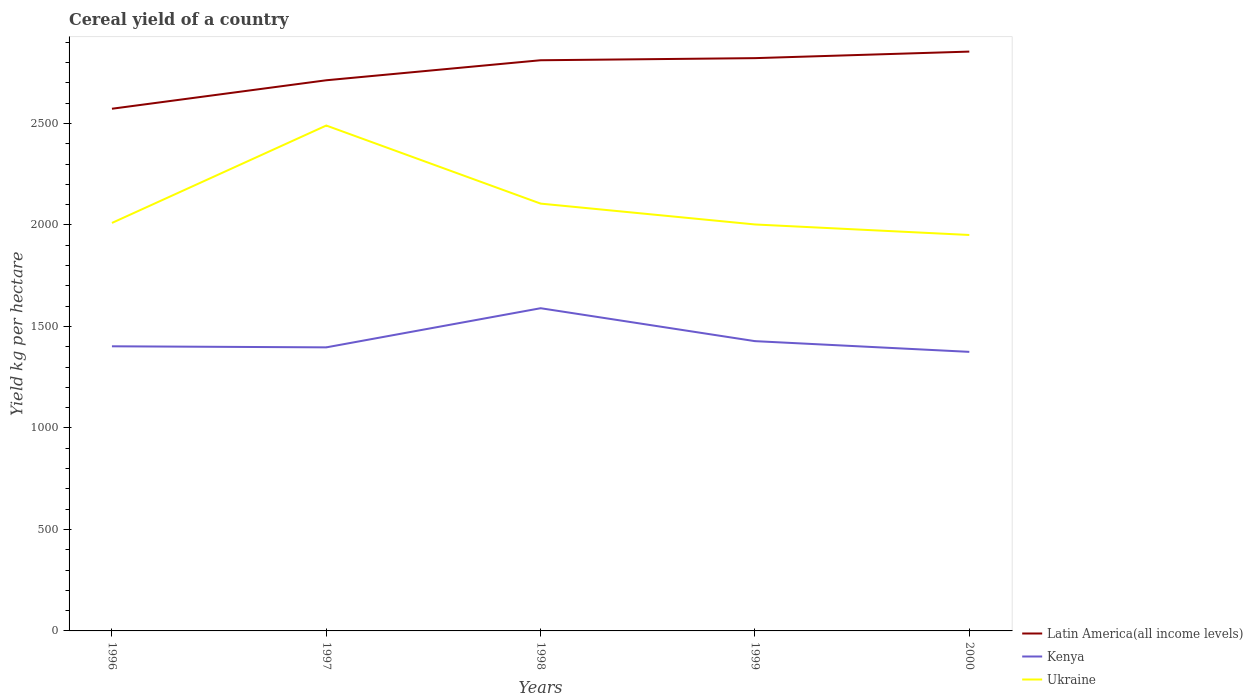How many different coloured lines are there?
Provide a short and direct response. 3. Does the line corresponding to Ukraine intersect with the line corresponding to Kenya?
Keep it short and to the point. No. Across all years, what is the maximum total cereal yield in Latin America(all income levels)?
Give a very brief answer. 2572.81. What is the total total cereal yield in Kenya in the graph?
Keep it short and to the point. 162.23. What is the difference between the highest and the second highest total cereal yield in Ukraine?
Ensure brevity in your answer.  539.33. How many lines are there?
Offer a very short reply. 3. How many years are there in the graph?
Give a very brief answer. 5. What is the difference between two consecutive major ticks on the Y-axis?
Offer a terse response. 500. Does the graph contain any zero values?
Your response must be concise. No. Where does the legend appear in the graph?
Offer a very short reply. Bottom right. What is the title of the graph?
Give a very brief answer. Cereal yield of a country. What is the label or title of the Y-axis?
Your answer should be very brief. Yield kg per hectare. What is the Yield kg per hectare in Latin America(all income levels) in 1996?
Offer a very short reply. 2572.81. What is the Yield kg per hectare in Kenya in 1996?
Keep it short and to the point. 1402.37. What is the Yield kg per hectare of Ukraine in 1996?
Provide a short and direct response. 2010.14. What is the Yield kg per hectare of Latin America(all income levels) in 1997?
Your answer should be compact. 2713.1. What is the Yield kg per hectare of Kenya in 1997?
Your answer should be compact. 1397.1. What is the Yield kg per hectare of Ukraine in 1997?
Offer a very short reply. 2490.11. What is the Yield kg per hectare of Latin America(all income levels) in 1998?
Offer a very short reply. 2811.75. What is the Yield kg per hectare in Kenya in 1998?
Provide a succinct answer. 1589.97. What is the Yield kg per hectare in Ukraine in 1998?
Offer a very short reply. 2105.38. What is the Yield kg per hectare of Latin America(all income levels) in 1999?
Ensure brevity in your answer.  2822.08. What is the Yield kg per hectare of Kenya in 1999?
Make the answer very short. 1427.74. What is the Yield kg per hectare of Ukraine in 1999?
Provide a succinct answer. 2002.63. What is the Yield kg per hectare of Latin America(all income levels) in 2000?
Ensure brevity in your answer.  2854.4. What is the Yield kg per hectare of Kenya in 2000?
Your answer should be very brief. 1374.96. What is the Yield kg per hectare of Ukraine in 2000?
Offer a very short reply. 1950.78. Across all years, what is the maximum Yield kg per hectare of Latin America(all income levels)?
Offer a very short reply. 2854.4. Across all years, what is the maximum Yield kg per hectare in Kenya?
Ensure brevity in your answer.  1589.97. Across all years, what is the maximum Yield kg per hectare of Ukraine?
Provide a succinct answer. 2490.11. Across all years, what is the minimum Yield kg per hectare of Latin America(all income levels)?
Keep it short and to the point. 2572.81. Across all years, what is the minimum Yield kg per hectare of Kenya?
Give a very brief answer. 1374.96. Across all years, what is the minimum Yield kg per hectare of Ukraine?
Provide a short and direct response. 1950.78. What is the total Yield kg per hectare of Latin America(all income levels) in the graph?
Your answer should be compact. 1.38e+04. What is the total Yield kg per hectare of Kenya in the graph?
Make the answer very short. 7192.14. What is the total Yield kg per hectare of Ukraine in the graph?
Offer a terse response. 1.06e+04. What is the difference between the Yield kg per hectare in Latin America(all income levels) in 1996 and that in 1997?
Provide a short and direct response. -140.3. What is the difference between the Yield kg per hectare in Kenya in 1996 and that in 1997?
Provide a short and direct response. 5.27. What is the difference between the Yield kg per hectare in Ukraine in 1996 and that in 1997?
Keep it short and to the point. -479.97. What is the difference between the Yield kg per hectare of Latin America(all income levels) in 1996 and that in 1998?
Your response must be concise. -238.94. What is the difference between the Yield kg per hectare of Kenya in 1996 and that in 1998?
Make the answer very short. -187.6. What is the difference between the Yield kg per hectare of Ukraine in 1996 and that in 1998?
Keep it short and to the point. -95.25. What is the difference between the Yield kg per hectare of Latin America(all income levels) in 1996 and that in 1999?
Make the answer very short. -249.27. What is the difference between the Yield kg per hectare in Kenya in 1996 and that in 1999?
Provide a succinct answer. -25.37. What is the difference between the Yield kg per hectare in Ukraine in 1996 and that in 1999?
Offer a very short reply. 7.5. What is the difference between the Yield kg per hectare of Latin America(all income levels) in 1996 and that in 2000?
Make the answer very short. -281.59. What is the difference between the Yield kg per hectare in Kenya in 1996 and that in 2000?
Provide a succinct answer. 27.41. What is the difference between the Yield kg per hectare of Ukraine in 1996 and that in 2000?
Keep it short and to the point. 59.36. What is the difference between the Yield kg per hectare in Latin America(all income levels) in 1997 and that in 1998?
Your response must be concise. -98.64. What is the difference between the Yield kg per hectare in Kenya in 1997 and that in 1998?
Your response must be concise. -192.87. What is the difference between the Yield kg per hectare in Ukraine in 1997 and that in 1998?
Give a very brief answer. 384.72. What is the difference between the Yield kg per hectare of Latin America(all income levels) in 1997 and that in 1999?
Offer a terse response. -108.97. What is the difference between the Yield kg per hectare of Kenya in 1997 and that in 1999?
Ensure brevity in your answer.  -30.64. What is the difference between the Yield kg per hectare in Ukraine in 1997 and that in 1999?
Ensure brevity in your answer.  487.47. What is the difference between the Yield kg per hectare in Latin America(all income levels) in 1997 and that in 2000?
Offer a terse response. -141.29. What is the difference between the Yield kg per hectare of Kenya in 1997 and that in 2000?
Ensure brevity in your answer.  22.14. What is the difference between the Yield kg per hectare of Ukraine in 1997 and that in 2000?
Your answer should be compact. 539.33. What is the difference between the Yield kg per hectare of Latin America(all income levels) in 1998 and that in 1999?
Ensure brevity in your answer.  -10.33. What is the difference between the Yield kg per hectare in Kenya in 1998 and that in 1999?
Keep it short and to the point. 162.23. What is the difference between the Yield kg per hectare in Ukraine in 1998 and that in 1999?
Your answer should be compact. 102.75. What is the difference between the Yield kg per hectare of Latin America(all income levels) in 1998 and that in 2000?
Offer a terse response. -42.65. What is the difference between the Yield kg per hectare in Kenya in 1998 and that in 2000?
Offer a terse response. 215. What is the difference between the Yield kg per hectare of Ukraine in 1998 and that in 2000?
Provide a succinct answer. 154.61. What is the difference between the Yield kg per hectare in Latin America(all income levels) in 1999 and that in 2000?
Your response must be concise. -32.32. What is the difference between the Yield kg per hectare in Kenya in 1999 and that in 2000?
Give a very brief answer. 52.78. What is the difference between the Yield kg per hectare in Ukraine in 1999 and that in 2000?
Offer a terse response. 51.86. What is the difference between the Yield kg per hectare in Latin America(all income levels) in 1996 and the Yield kg per hectare in Kenya in 1997?
Your response must be concise. 1175.71. What is the difference between the Yield kg per hectare of Latin America(all income levels) in 1996 and the Yield kg per hectare of Ukraine in 1997?
Your answer should be very brief. 82.7. What is the difference between the Yield kg per hectare in Kenya in 1996 and the Yield kg per hectare in Ukraine in 1997?
Give a very brief answer. -1087.73. What is the difference between the Yield kg per hectare in Latin America(all income levels) in 1996 and the Yield kg per hectare in Kenya in 1998?
Your answer should be very brief. 982.84. What is the difference between the Yield kg per hectare in Latin America(all income levels) in 1996 and the Yield kg per hectare in Ukraine in 1998?
Give a very brief answer. 467.42. What is the difference between the Yield kg per hectare in Kenya in 1996 and the Yield kg per hectare in Ukraine in 1998?
Make the answer very short. -703.01. What is the difference between the Yield kg per hectare in Latin America(all income levels) in 1996 and the Yield kg per hectare in Kenya in 1999?
Offer a very short reply. 1145.06. What is the difference between the Yield kg per hectare in Latin America(all income levels) in 1996 and the Yield kg per hectare in Ukraine in 1999?
Keep it short and to the point. 570.17. What is the difference between the Yield kg per hectare in Kenya in 1996 and the Yield kg per hectare in Ukraine in 1999?
Offer a terse response. -600.26. What is the difference between the Yield kg per hectare of Latin America(all income levels) in 1996 and the Yield kg per hectare of Kenya in 2000?
Provide a short and direct response. 1197.84. What is the difference between the Yield kg per hectare of Latin America(all income levels) in 1996 and the Yield kg per hectare of Ukraine in 2000?
Provide a short and direct response. 622.03. What is the difference between the Yield kg per hectare in Kenya in 1996 and the Yield kg per hectare in Ukraine in 2000?
Offer a very short reply. -548.41. What is the difference between the Yield kg per hectare in Latin America(all income levels) in 1997 and the Yield kg per hectare in Kenya in 1998?
Make the answer very short. 1123.14. What is the difference between the Yield kg per hectare of Latin America(all income levels) in 1997 and the Yield kg per hectare of Ukraine in 1998?
Provide a short and direct response. 607.72. What is the difference between the Yield kg per hectare in Kenya in 1997 and the Yield kg per hectare in Ukraine in 1998?
Your response must be concise. -708.28. What is the difference between the Yield kg per hectare of Latin America(all income levels) in 1997 and the Yield kg per hectare of Kenya in 1999?
Your answer should be very brief. 1285.36. What is the difference between the Yield kg per hectare of Latin America(all income levels) in 1997 and the Yield kg per hectare of Ukraine in 1999?
Give a very brief answer. 710.47. What is the difference between the Yield kg per hectare of Kenya in 1997 and the Yield kg per hectare of Ukraine in 1999?
Make the answer very short. -605.53. What is the difference between the Yield kg per hectare of Latin America(all income levels) in 1997 and the Yield kg per hectare of Kenya in 2000?
Make the answer very short. 1338.14. What is the difference between the Yield kg per hectare of Latin America(all income levels) in 1997 and the Yield kg per hectare of Ukraine in 2000?
Provide a short and direct response. 762.33. What is the difference between the Yield kg per hectare in Kenya in 1997 and the Yield kg per hectare in Ukraine in 2000?
Offer a very short reply. -553.68. What is the difference between the Yield kg per hectare in Latin America(all income levels) in 1998 and the Yield kg per hectare in Kenya in 1999?
Make the answer very short. 1384.01. What is the difference between the Yield kg per hectare of Latin America(all income levels) in 1998 and the Yield kg per hectare of Ukraine in 1999?
Provide a succinct answer. 809.12. What is the difference between the Yield kg per hectare in Kenya in 1998 and the Yield kg per hectare in Ukraine in 1999?
Your answer should be very brief. -412.67. What is the difference between the Yield kg per hectare in Latin America(all income levels) in 1998 and the Yield kg per hectare in Kenya in 2000?
Provide a succinct answer. 1436.79. What is the difference between the Yield kg per hectare of Latin America(all income levels) in 1998 and the Yield kg per hectare of Ukraine in 2000?
Ensure brevity in your answer.  860.97. What is the difference between the Yield kg per hectare in Kenya in 1998 and the Yield kg per hectare in Ukraine in 2000?
Offer a terse response. -360.81. What is the difference between the Yield kg per hectare in Latin America(all income levels) in 1999 and the Yield kg per hectare in Kenya in 2000?
Your response must be concise. 1447.12. What is the difference between the Yield kg per hectare in Latin America(all income levels) in 1999 and the Yield kg per hectare in Ukraine in 2000?
Offer a very short reply. 871.3. What is the difference between the Yield kg per hectare of Kenya in 1999 and the Yield kg per hectare of Ukraine in 2000?
Provide a succinct answer. -523.03. What is the average Yield kg per hectare of Latin America(all income levels) per year?
Make the answer very short. 2754.83. What is the average Yield kg per hectare in Kenya per year?
Provide a succinct answer. 1438.43. What is the average Yield kg per hectare of Ukraine per year?
Give a very brief answer. 2111.81. In the year 1996, what is the difference between the Yield kg per hectare in Latin America(all income levels) and Yield kg per hectare in Kenya?
Offer a very short reply. 1170.43. In the year 1996, what is the difference between the Yield kg per hectare of Latin America(all income levels) and Yield kg per hectare of Ukraine?
Your response must be concise. 562.67. In the year 1996, what is the difference between the Yield kg per hectare of Kenya and Yield kg per hectare of Ukraine?
Provide a succinct answer. -607.77. In the year 1997, what is the difference between the Yield kg per hectare in Latin America(all income levels) and Yield kg per hectare in Kenya?
Offer a terse response. 1316.01. In the year 1997, what is the difference between the Yield kg per hectare of Latin America(all income levels) and Yield kg per hectare of Ukraine?
Your response must be concise. 223. In the year 1997, what is the difference between the Yield kg per hectare in Kenya and Yield kg per hectare in Ukraine?
Keep it short and to the point. -1093.01. In the year 1998, what is the difference between the Yield kg per hectare in Latin America(all income levels) and Yield kg per hectare in Kenya?
Give a very brief answer. 1221.78. In the year 1998, what is the difference between the Yield kg per hectare in Latin America(all income levels) and Yield kg per hectare in Ukraine?
Your answer should be very brief. 706.36. In the year 1998, what is the difference between the Yield kg per hectare of Kenya and Yield kg per hectare of Ukraine?
Give a very brief answer. -515.42. In the year 1999, what is the difference between the Yield kg per hectare in Latin America(all income levels) and Yield kg per hectare in Kenya?
Offer a very short reply. 1394.34. In the year 1999, what is the difference between the Yield kg per hectare in Latin America(all income levels) and Yield kg per hectare in Ukraine?
Offer a very short reply. 819.45. In the year 1999, what is the difference between the Yield kg per hectare of Kenya and Yield kg per hectare of Ukraine?
Offer a very short reply. -574.89. In the year 2000, what is the difference between the Yield kg per hectare in Latin America(all income levels) and Yield kg per hectare in Kenya?
Provide a succinct answer. 1479.43. In the year 2000, what is the difference between the Yield kg per hectare in Latin America(all income levels) and Yield kg per hectare in Ukraine?
Make the answer very short. 903.62. In the year 2000, what is the difference between the Yield kg per hectare of Kenya and Yield kg per hectare of Ukraine?
Make the answer very short. -575.81. What is the ratio of the Yield kg per hectare of Latin America(all income levels) in 1996 to that in 1997?
Ensure brevity in your answer.  0.95. What is the ratio of the Yield kg per hectare of Kenya in 1996 to that in 1997?
Offer a very short reply. 1. What is the ratio of the Yield kg per hectare in Ukraine in 1996 to that in 1997?
Offer a terse response. 0.81. What is the ratio of the Yield kg per hectare in Latin America(all income levels) in 1996 to that in 1998?
Make the answer very short. 0.92. What is the ratio of the Yield kg per hectare in Kenya in 1996 to that in 1998?
Provide a short and direct response. 0.88. What is the ratio of the Yield kg per hectare in Ukraine in 1996 to that in 1998?
Your answer should be compact. 0.95. What is the ratio of the Yield kg per hectare in Latin America(all income levels) in 1996 to that in 1999?
Give a very brief answer. 0.91. What is the ratio of the Yield kg per hectare in Kenya in 1996 to that in 1999?
Provide a short and direct response. 0.98. What is the ratio of the Yield kg per hectare of Latin America(all income levels) in 1996 to that in 2000?
Give a very brief answer. 0.9. What is the ratio of the Yield kg per hectare in Kenya in 1996 to that in 2000?
Your answer should be very brief. 1.02. What is the ratio of the Yield kg per hectare in Ukraine in 1996 to that in 2000?
Keep it short and to the point. 1.03. What is the ratio of the Yield kg per hectare in Latin America(all income levels) in 1997 to that in 1998?
Provide a succinct answer. 0.96. What is the ratio of the Yield kg per hectare in Kenya in 1997 to that in 1998?
Provide a succinct answer. 0.88. What is the ratio of the Yield kg per hectare of Ukraine in 1997 to that in 1998?
Your response must be concise. 1.18. What is the ratio of the Yield kg per hectare in Latin America(all income levels) in 1997 to that in 1999?
Ensure brevity in your answer.  0.96. What is the ratio of the Yield kg per hectare in Kenya in 1997 to that in 1999?
Ensure brevity in your answer.  0.98. What is the ratio of the Yield kg per hectare in Ukraine in 1997 to that in 1999?
Your answer should be compact. 1.24. What is the ratio of the Yield kg per hectare of Latin America(all income levels) in 1997 to that in 2000?
Make the answer very short. 0.95. What is the ratio of the Yield kg per hectare in Kenya in 1997 to that in 2000?
Offer a terse response. 1.02. What is the ratio of the Yield kg per hectare in Ukraine in 1997 to that in 2000?
Ensure brevity in your answer.  1.28. What is the ratio of the Yield kg per hectare of Latin America(all income levels) in 1998 to that in 1999?
Ensure brevity in your answer.  1. What is the ratio of the Yield kg per hectare in Kenya in 1998 to that in 1999?
Keep it short and to the point. 1.11. What is the ratio of the Yield kg per hectare of Ukraine in 1998 to that in 1999?
Offer a very short reply. 1.05. What is the ratio of the Yield kg per hectare of Latin America(all income levels) in 1998 to that in 2000?
Offer a very short reply. 0.99. What is the ratio of the Yield kg per hectare in Kenya in 1998 to that in 2000?
Your answer should be very brief. 1.16. What is the ratio of the Yield kg per hectare in Ukraine in 1998 to that in 2000?
Provide a short and direct response. 1.08. What is the ratio of the Yield kg per hectare of Latin America(all income levels) in 1999 to that in 2000?
Give a very brief answer. 0.99. What is the ratio of the Yield kg per hectare in Kenya in 1999 to that in 2000?
Offer a very short reply. 1.04. What is the ratio of the Yield kg per hectare of Ukraine in 1999 to that in 2000?
Keep it short and to the point. 1.03. What is the difference between the highest and the second highest Yield kg per hectare of Latin America(all income levels)?
Keep it short and to the point. 32.32. What is the difference between the highest and the second highest Yield kg per hectare of Kenya?
Offer a very short reply. 162.23. What is the difference between the highest and the second highest Yield kg per hectare of Ukraine?
Keep it short and to the point. 384.72. What is the difference between the highest and the lowest Yield kg per hectare in Latin America(all income levels)?
Provide a short and direct response. 281.59. What is the difference between the highest and the lowest Yield kg per hectare of Kenya?
Give a very brief answer. 215. What is the difference between the highest and the lowest Yield kg per hectare of Ukraine?
Ensure brevity in your answer.  539.33. 